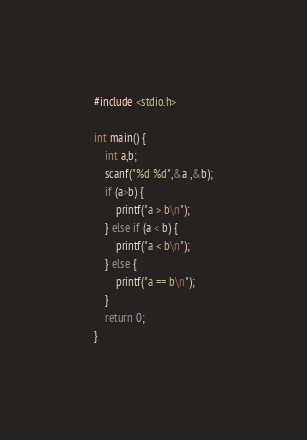<code> <loc_0><loc_0><loc_500><loc_500><_C_>#include <stdio.h>

int main() {
	int a,b;
	scanf("%d %d",&a ,&b);
	if (a>b) {
		printf("a > b\n");
	} else if (a < b) {
		printf("a < b\n");
	} else {
		printf("a == b\n");
	}
  	return 0;
}</code> 